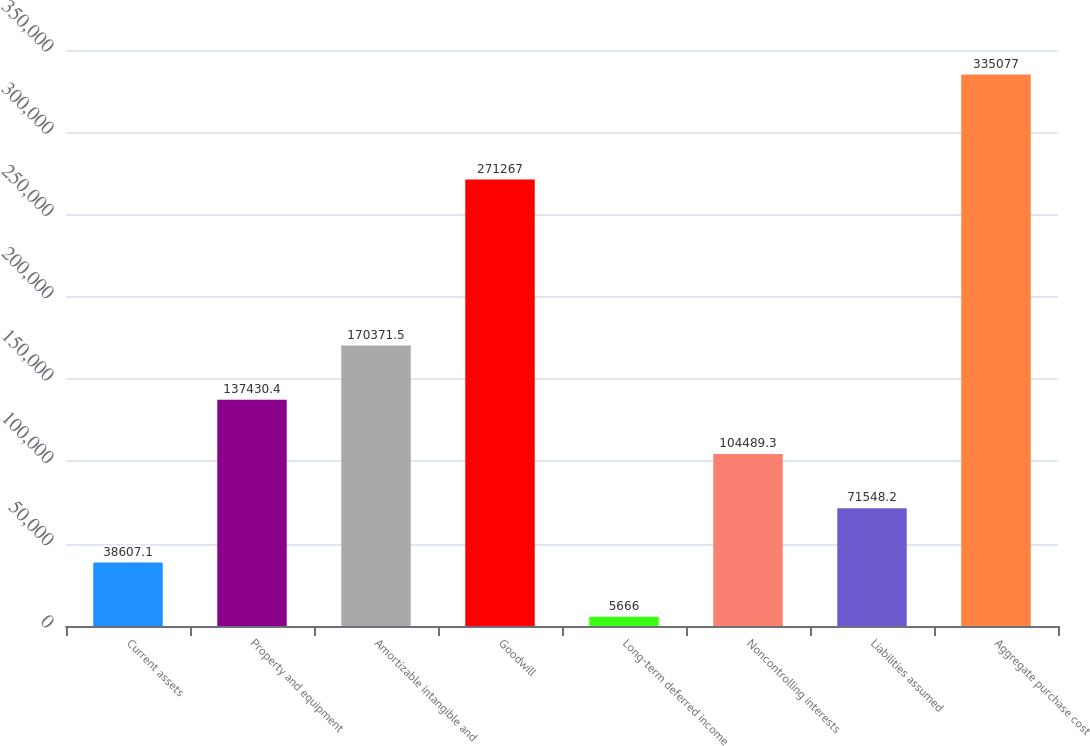<chart> <loc_0><loc_0><loc_500><loc_500><bar_chart><fcel>Current assets<fcel>Property and equipment<fcel>Amortizable intangible and<fcel>Goodwill<fcel>Long-term deferred income<fcel>Noncontrolling interests<fcel>Liabilities assumed<fcel>Aggregate purchase cost<nl><fcel>38607.1<fcel>137430<fcel>170372<fcel>271267<fcel>5666<fcel>104489<fcel>71548.2<fcel>335077<nl></chart> 